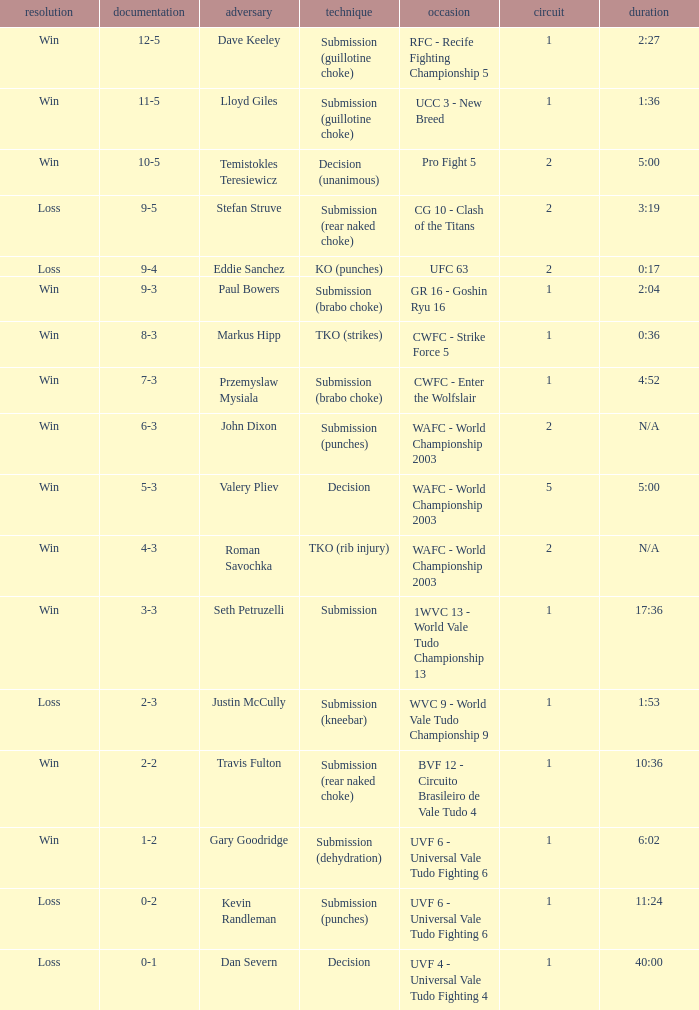What round has the highest Res loss, and a time of 40:00? 1.0. 